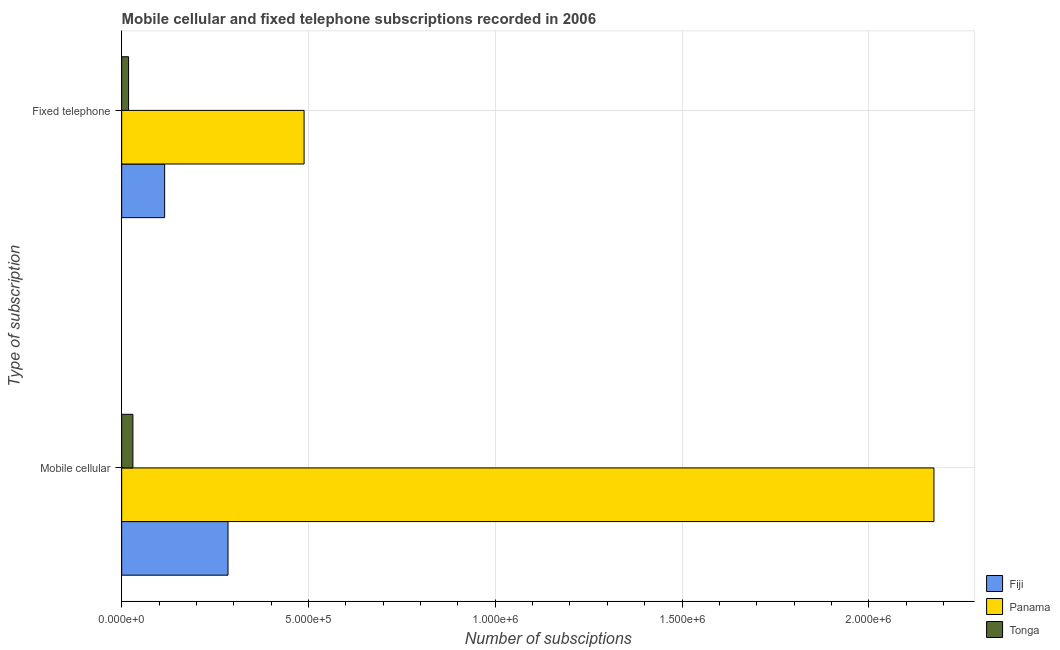How many different coloured bars are there?
Your response must be concise. 3. How many groups of bars are there?
Offer a very short reply. 2. Are the number of bars on each tick of the Y-axis equal?
Keep it short and to the point. Yes. How many bars are there on the 1st tick from the top?
Your answer should be very brief. 3. How many bars are there on the 2nd tick from the bottom?
Offer a very short reply. 3. What is the label of the 2nd group of bars from the top?
Provide a short and direct response. Mobile cellular. What is the number of fixed telephone subscriptions in Fiji?
Make the answer very short. 1.15e+05. Across all countries, what is the maximum number of fixed telephone subscriptions?
Provide a succinct answer. 4.88e+05. Across all countries, what is the minimum number of mobile cellular subscriptions?
Keep it short and to the point. 3.01e+04. In which country was the number of fixed telephone subscriptions maximum?
Your response must be concise. Panama. In which country was the number of fixed telephone subscriptions minimum?
Give a very brief answer. Tonga. What is the total number of mobile cellular subscriptions in the graph?
Your response must be concise. 2.49e+06. What is the difference between the number of mobile cellular subscriptions in Tonga and that in Fiji?
Your response must be concise. -2.55e+05. What is the difference between the number of fixed telephone subscriptions in Panama and the number of mobile cellular subscriptions in Fiji?
Offer a very short reply. 2.04e+05. What is the average number of fixed telephone subscriptions per country?
Your answer should be very brief. 2.07e+05. What is the difference between the number of fixed telephone subscriptions and number of mobile cellular subscriptions in Panama?
Keep it short and to the point. -1.69e+06. In how many countries, is the number of fixed telephone subscriptions greater than 100000 ?
Ensure brevity in your answer.  2. What is the ratio of the number of mobile cellular subscriptions in Fiji to that in Panama?
Keep it short and to the point. 0.13. Is the number of mobile cellular subscriptions in Panama less than that in Tonga?
Your response must be concise. No. What does the 1st bar from the top in Fixed telephone represents?
Offer a very short reply. Tonga. What does the 3rd bar from the bottom in Mobile cellular represents?
Your answer should be compact. Tonga. How many countries are there in the graph?
Offer a very short reply. 3. What is the difference between two consecutive major ticks on the X-axis?
Make the answer very short. 5.00e+05. Are the values on the major ticks of X-axis written in scientific E-notation?
Provide a succinct answer. Yes. Does the graph contain any zero values?
Offer a very short reply. No. What is the title of the graph?
Your answer should be very brief. Mobile cellular and fixed telephone subscriptions recorded in 2006. What is the label or title of the X-axis?
Your response must be concise. Number of subsciptions. What is the label or title of the Y-axis?
Offer a very short reply. Type of subscription. What is the Number of subsciptions in Fiji in Mobile cellular?
Ensure brevity in your answer.  2.85e+05. What is the Number of subsciptions in Panama in Mobile cellular?
Your response must be concise. 2.17e+06. What is the Number of subsciptions in Tonga in Mobile cellular?
Offer a terse response. 3.01e+04. What is the Number of subsciptions of Fiji in Fixed telephone?
Provide a short and direct response. 1.15e+05. What is the Number of subsciptions in Panama in Fixed telephone?
Your response must be concise. 4.88e+05. What is the Number of subsciptions in Tonga in Fixed telephone?
Ensure brevity in your answer.  1.84e+04. Across all Type of subscription, what is the maximum Number of subsciptions in Fiji?
Your response must be concise. 2.85e+05. Across all Type of subscription, what is the maximum Number of subsciptions of Panama?
Your response must be concise. 2.17e+06. Across all Type of subscription, what is the maximum Number of subsciptions in Tonga?
Offer a terse response. 3.01e+04. Across all Type of subscription, what is the minimum Number of subsciptions in Fiji?
Offer a very short reply. 1.15e+05. Across all Type of subscription, what is the minimum Number of subsciptions in Panama?
Keep it short and to the point. 4.88e+05. Across all Type of subscription, what is the minimum Number of subsciptions of Tonga?
Provide a short and direct response. 1.84e+04. What is the total Number of subsciptions of Fiji in the graph?
Provide a succinct answer. 4.00e+05. What is the total Number of subsciptions of Panama in the graph?
Provide a succinct answer. 2.66e+06. What is the total Number of subsciptions of Tonga in the graph?
Ensure brevity in your answer.  4.85e+04. What is the difference between the Number of subsciptions in Fiji in Mobile cellular and that in Fixed telephone?
Offer a very short reply. 1.70e+05. What is the difference between the Number of subsciptions in Panama in Mobile cellular and that in Fixed telephone?
Provide a short and direct response. 1.69e+06. What is the difference between the Number of subsciptions of Tonga in Mobile cellular and that in Fixed telephone?
Your answer should be compact. 1.16e+04. What is the difference between the Number of subsciptions of Fiji in Mobile cellular and the Number of subsciptions of Panama in Fixed telephone?
Provide a short and direct response. -2.04e+05. What is the difference between the Number of subsciptions of Fiji in Mobile cellular and the Number of subsciptions of Tonga in Fixed telephone?
Give a very brief answer. 2.66e+05. What is the difference between the Number of subsciptions of Panama in Mobile cellular and the Number of subsciptions of Tonga in Fixed telephone?
Offer a very short reply. 2.16e+06. What is the average Number of subsciptions in Fiji per Type of subscription?
Provide a succinct answer. 2.00e+05. What is the average Number of subsciptions of Panama per Type of subscription?
Offer a very short reply. 1.33e+06. What is the average Number of subsciptions of Tonga per Type of subscription?
Offer a terse response. 2.42e+04. What is the difference between the Number of subsciptions of Fiji and Number of subsciptions of Panama in Mobile cellular?
Ensure brevity in your answer.  -1.89e+06. What is the difference between the Number of subsciptions of Fiji and Number of subsciptions of Tonga in Mobile cellular?
Your response must be concise. 2.55e+05. What is the difference between the Number of subsciptions in Panama and Number of subsciptions in Tonga in Mobile cellular?
Provide a short and direct response. 2.14e+06. What is the difference between the Number of subsciptions of Fiji and Number of subsciptions of Panama in Fixed telephone?
Ensure brevity in your answer.  -3.73e+05. What is the difference between the Number of subsciptions of Fiji and Number of subsciptions of Tonga in Fixed telephone?
Make the answer very short. 9.66e+04. What is the difference between the Number of subsciptions in Panama and Number of subsciptions in Tonga in Fixed telephone?
Offer a very short reply. 4.70e+05. What is the ratio of the Number of subsciptions in Fiji in Mobile cellular to that in Fixed telephone?
Your answer should be very brief. 2.48. What is the ratio of the Number of subsciptions in Panama in Mobile cellular to that in Fixed telephone?
Offer a terse response. 4.45. What is the ratio of the Number of subsciptions of Tonga in Mobile cellular to that in Fixed telephone?
Ensure brevity in your answer.  1.63. What is the difference between the highest and the second highest Number of subsciptions of Fiji?
Offer a terse response. 1.70e+05. What is the difference between the highest and the second highest Number of subsciptions of Panama?
Ensure brevity in your answer.  1.69e+06. What is the difference between the highest and the second highest Number of subsciptions of Tonga?
Make the answer very short. 1.16e+04. What is the difference between the highest and the lowest Number of subsciptions in Fiji?
Offer a terse response. 1.70e+05. What is the difference between the highest and the lowest Number of subsciptions of Panama?
Ensure brevity in your answer.  1.69e+06. What is the difference between the highest and the lowest Number of subsciptions of Tonga?
Ensure brevity in your answer.  1.16e+04. 